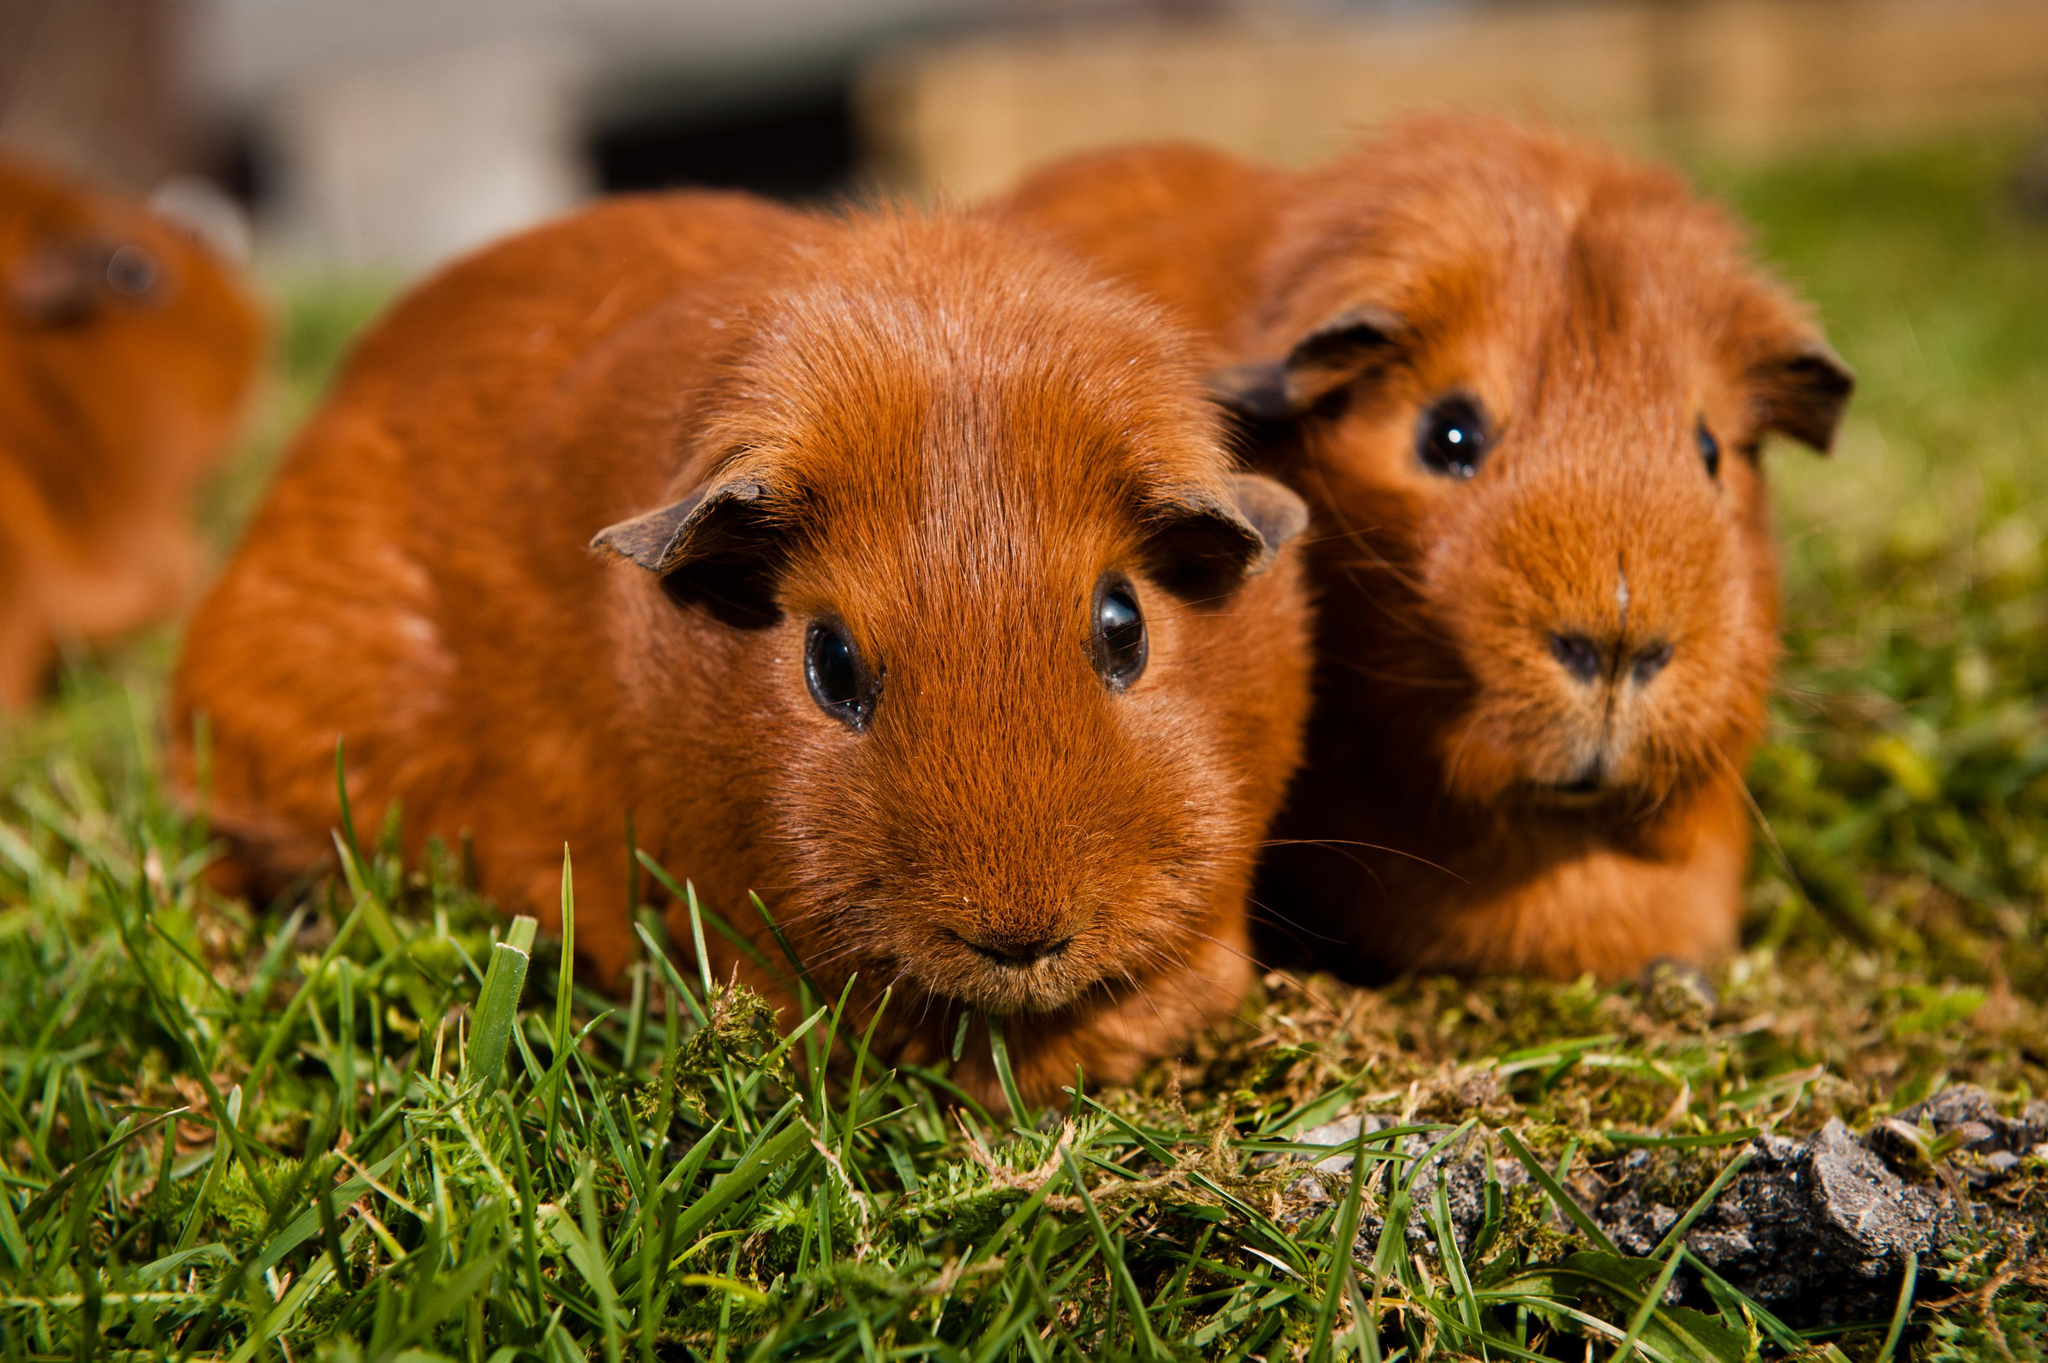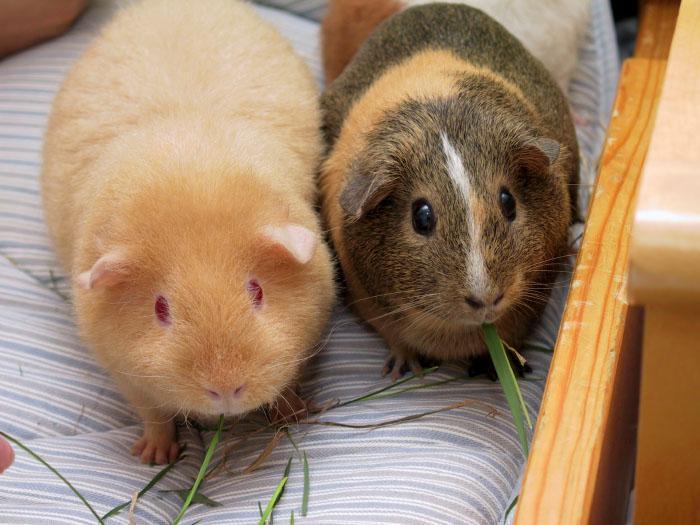The first image is the image on the left, the second image is the image on the right. For the images shown, is this caption "Each image contains the same number of guinea pigs, and all animals share similar poses." true? Answer yes or no. Yes. 